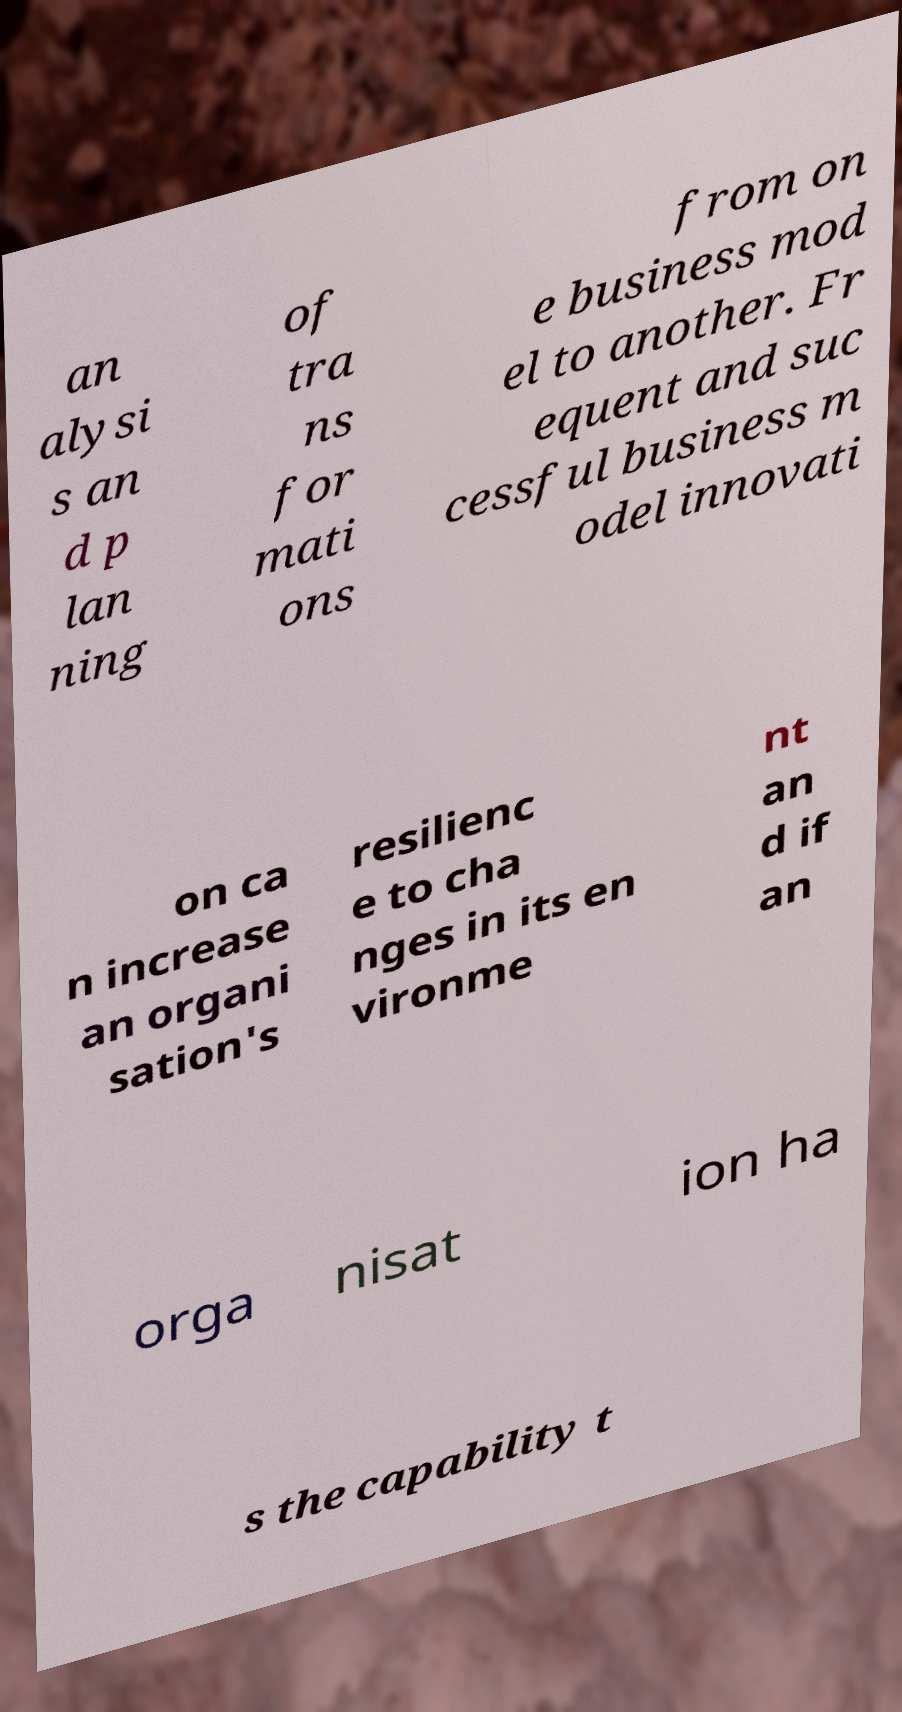For documentation purposes, I need the text within this image transcribed. Could you provide that? an alysi s an d p lan ning of tra ns for mati ons from on e business mod el to another. Fr equent and suc cessful business m odel innovati on ca n increase an organi sation's resilienc e to cha nges in its en vironme nt an d if an orga nisat ion ha s the capability t 